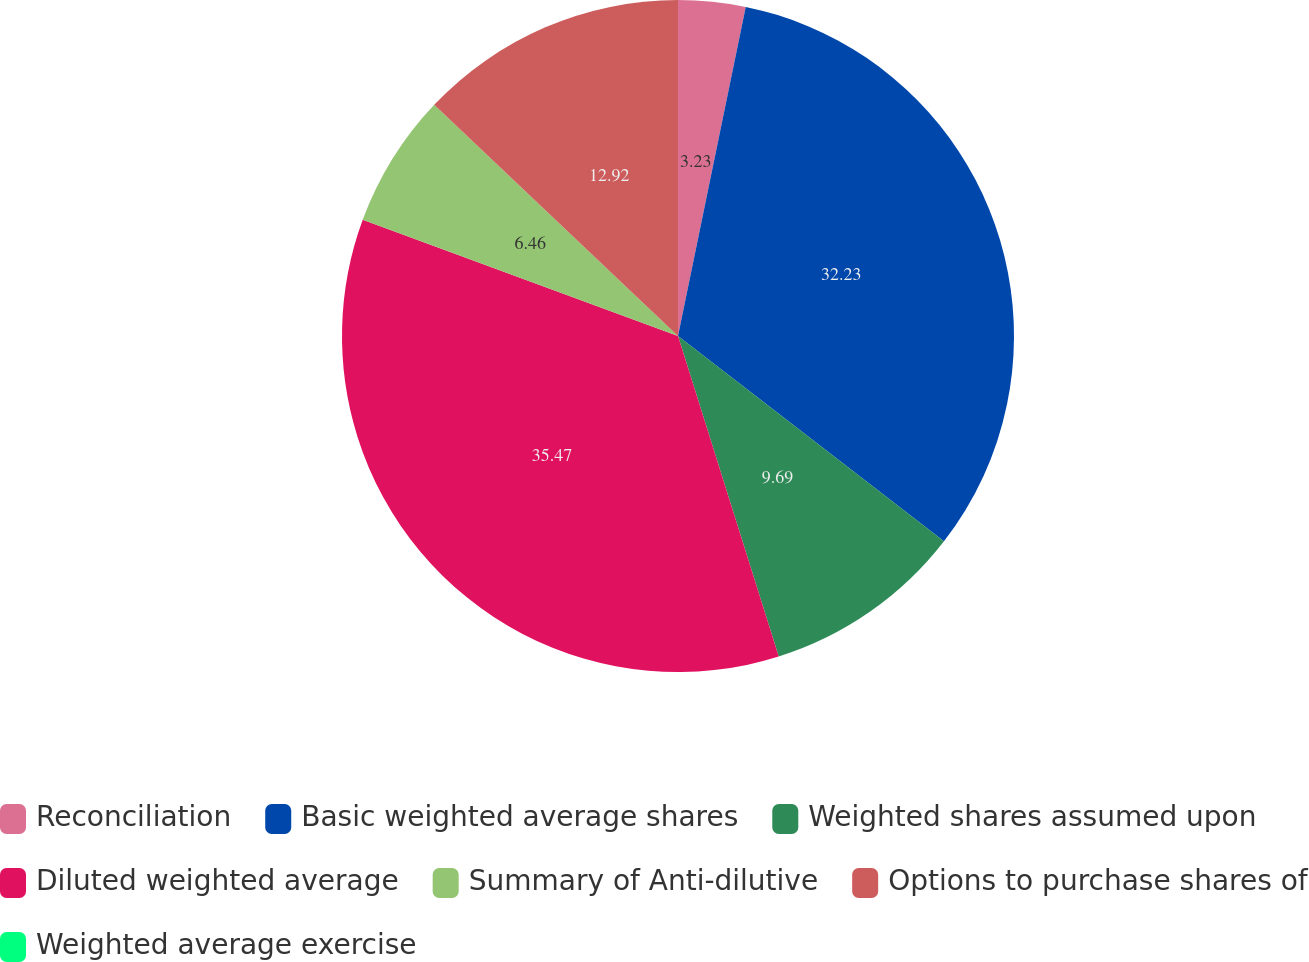Convert chart to OTSL. <chart><loc_0><loc_0><loc_500><loc_500><pie_chart><fcel>Reconciliation<fcel>Basic weighted average shares<fcel>Weighted shares assumed upon<fcel>Diluted weighted average<fcel>Summary of Anti-dilutive<fcel>Options to purchase shares of<fcel>Weighted average exercise<nl><fcel>3.23%<fcel>32.23%<fcel>9.69%<fcel>35.46%<fcel>6.46%<fcel>12.92%<fcel>0.0%<nl></chart> 